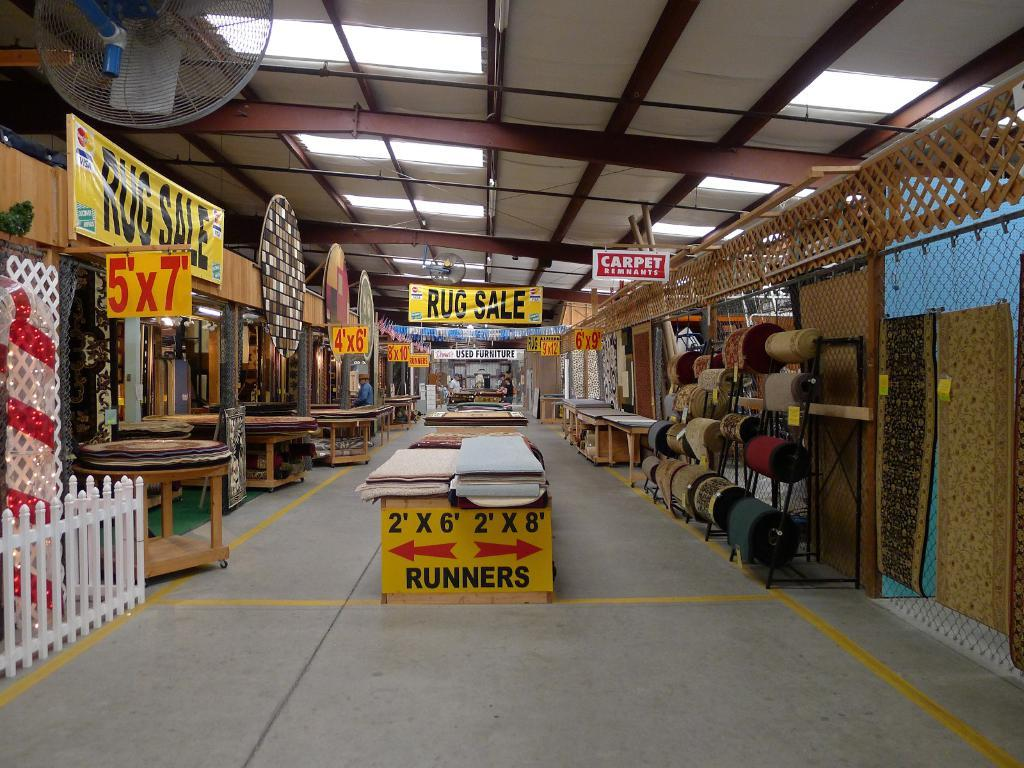<image>
Summarize the visual content of the image. A couple signs that say runners and rug sale 